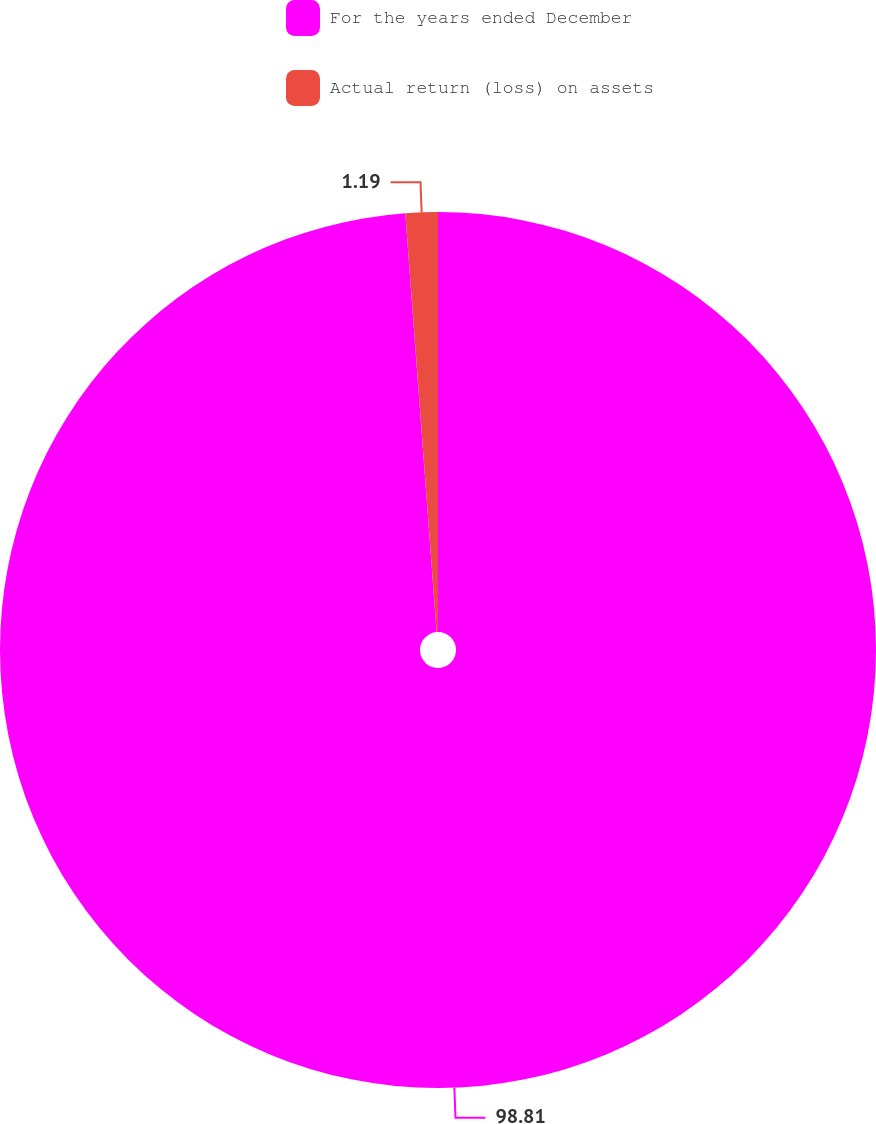<chart> <loc_0><loc_0><loc_500><loc_500><pie_chart><fcel>For the years ended December<fcel>Actual return (loss) on assets<nl><fcel>98.81%<fcel>1.19%<nl></chart> 